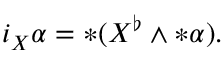<formula> <loc_0><loc_0><loc_500><loc_500>i _ { X } \alpha = \ast ( X ^ { \flat } \wedge \ast \alpha ) .</formula> 